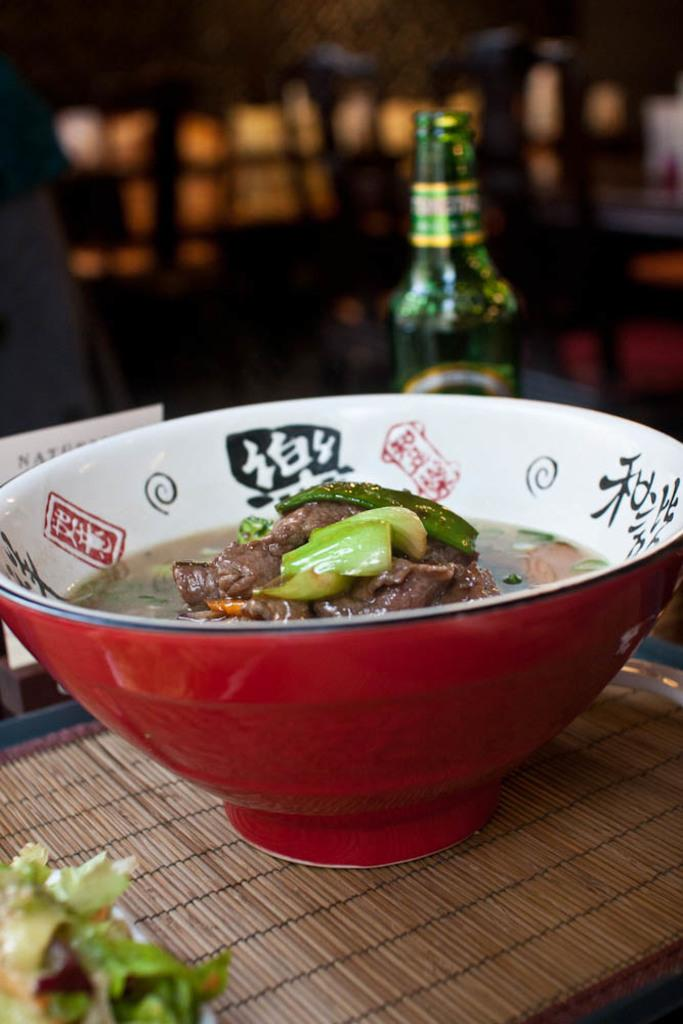What object can be seen in the image that typically contains a liquid? There is a bottle in the image. What other container is visible in the image? There is a bowl in the image. What is inside the bowl? There are eating items in the bowl. What type of death is depicted in the image? There is no depiction of death in the image; it features a bottle and a bowl with eating items. What type of cannon is visible in the image? There is no cannon present in the image. What type of toy can be seen in the image? There is no toy present in the image. 